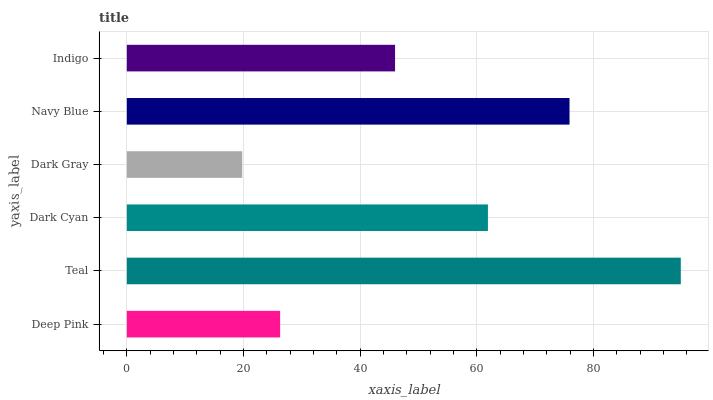Is Dark Gray the minimum?
Answer yes or no. Yes. Is Teal the maximum?
Answer yes or no. Yes. Is Dark Cyan the minimum?
Answer yes or no. No. Is Dark Cyan the maximum?
Answer yes or no. No. Is Teal greater than Dark Cyan?
Answer yes or no. Yes. Is Dark Cyan less than Teal?
Answer yes or no. Yes. Is Dark Cyan greater than Teal?
Answer yes or no. No. Is Teal less than Dark Cyan?
Answer yes or no. No. Is Dark Cyan the high median?
Answer yes or no. Yes. Is Indigo the low median?
Answer yes or no. Yes. Is Teal the high median?
Answer yes or no. No. Is Teal the low median?
Answer yes or no. No. 